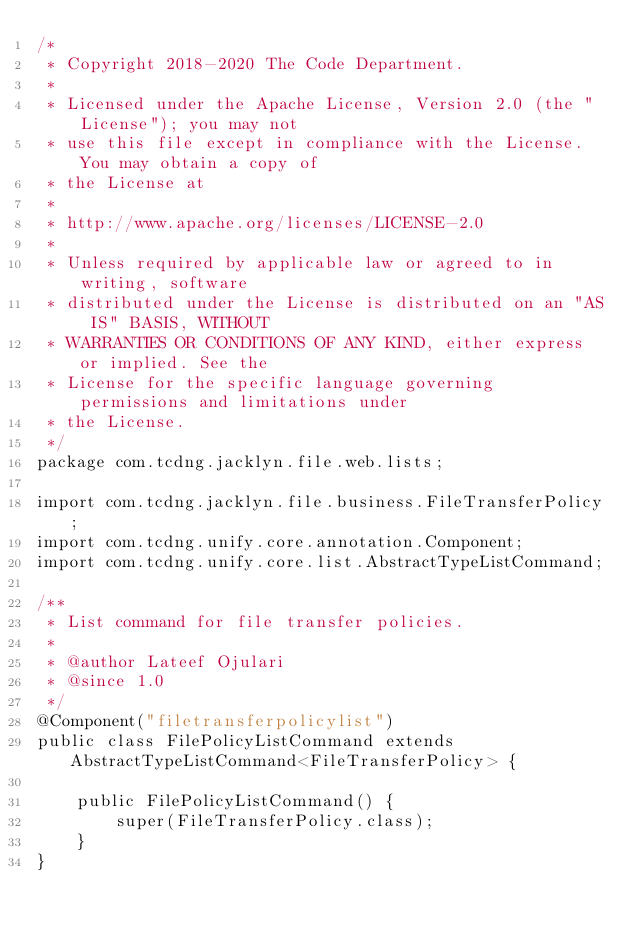<code> <loc_0><loc_0><loc_500><loc_500><_Java_>/*
 * Copyright 2018-2020 The Code Department.
 * 
 * Licensed under the Apache License, Version 2.0 (the "License"); you may not
 * use this file except in compliance with the License. You may obtain a copy of
 * the License at
 * 
 * http://www.apache.org/licenses/LICENSE-2.0
 * 
 * Unless required by applicable law or agreed to in writing, software
 * distributed under the License is distributed on an "AS IS" BASIS, WITHOUT
 * WARRANTIES OR CONDITIONS OF ANY KIND, either express or implied. See the
 * License for the specific language governing permissions and limitations under
 * the License.
 */
package com.tcdng.jacklyn.file.web.lists;

import com.tcdng.jacklyn.file.business.FileTransferPolicy;
import com.tcdng.unify.core.annotation.Component;
import com.tcdng.unify.core.list.AbstractTypeListCommand;

/**
 * List command for file transfer policies.
 * 
 * @author Lateef Ojulari
 * @since 1.0
 */
@Component("filetransferpolicylist")
public class FilePolicyListCommand extends AbstractTypeListCommand<FileTransferPolicy> {

    public FilePolicyListCommand() {
        super(FileTransferPolicy.class);
    }
}
</code> 